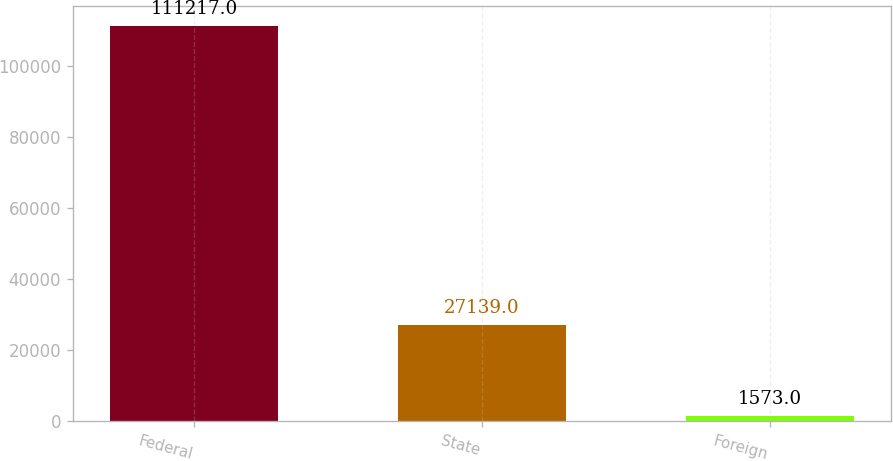Convert chart to OTSL. <chart><loc_0><loc_0><loc_500><loc_500><bar_chart><fcel>Federal<fcel>State<fcel>Foreign<nl><fcel>111217<fcel>27139<fcel>1573<nl></chart> 